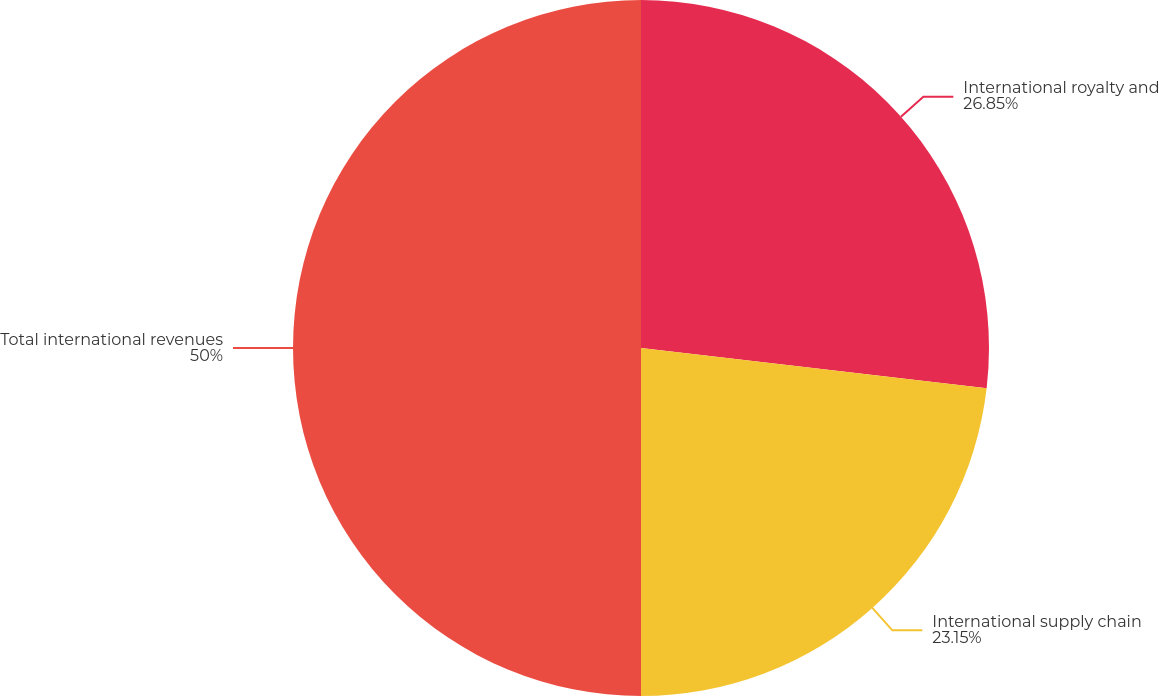Convert chart to OTSL. <chart><loc_0><loc_0><loc_500><loc_500><pie_chart><fcel>International royalty and<fcel>International supply chain<fcel>Total international revenues<nl><fcel>26.85%<fcel>23.15%<fcel>50.0%<nl></chart> 